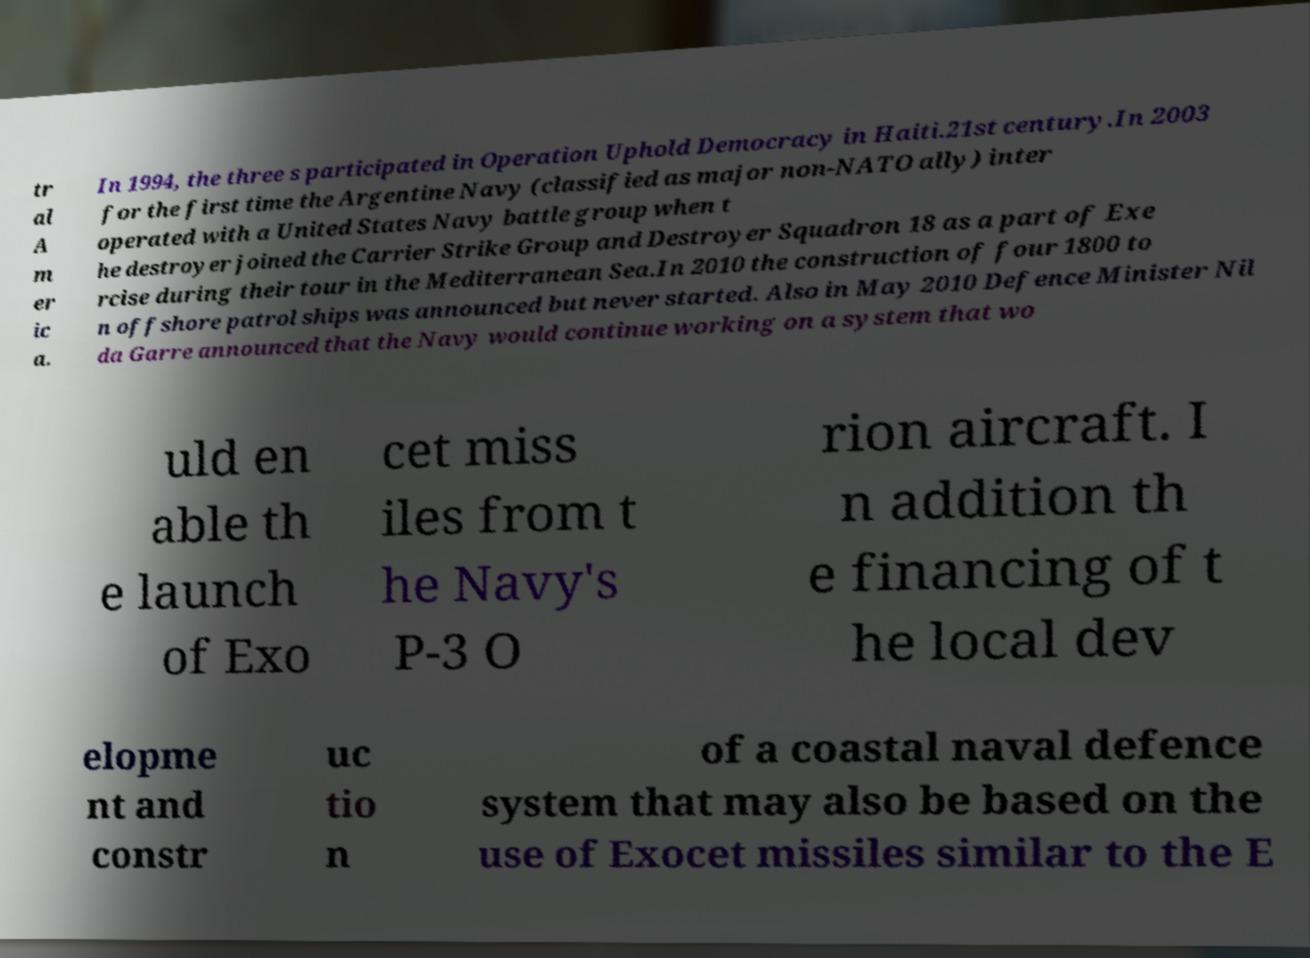Can you accurately transcribe the text from the provided image for me? tr al A m er ic a. In 1994, the three s participated in Operation Uphold Democracy in Haiti.21st century.In 2003 for the first time the Argentine Navy (classified as major non-NATO ally) inter operated with a United States Navy battle group when t he destroyer joined the Carrier Strike Group and Destroyer Squadron 18 as a part of Exe rcise during their tour in the Mediterranean Sea.In 2010 the construction of four 1800 to n offshore patrol ships was announced but never started. Also in May 2010 Defence Minister Nil da Garre announced that the Navy would continue working on a system that wo uld en able th e launch of Exo cet miss iles from t he Navy's P-3 O rion aircraft. I n addition th e financing of t he local dev elopme nt and constr uc tio n of a coastal naval defence system that may also be based on the use of Exocet missiles similar to the E 